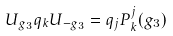Convert formula to latex. <formula><loc_0><loc_0><loc_500><loc_500>U _ { g _ { 3 } } q _ { k } U _ { - g _ { 3 } } = q _ { j } P ^ { j } _ { k } ( g _ { 3 } )</formula> 